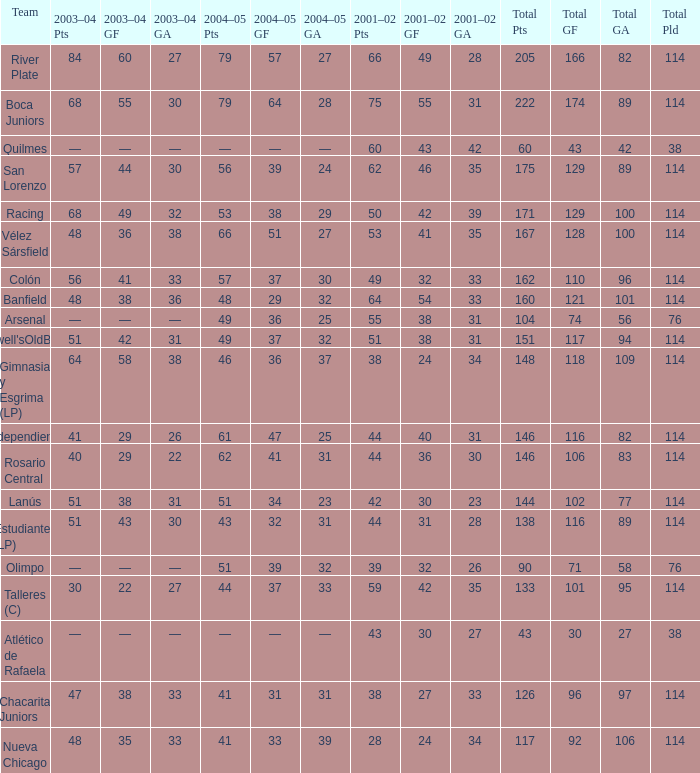Which Team has a Total Pld smaller than 114, and a 2004–05 Pts of 49? Arsenal. 